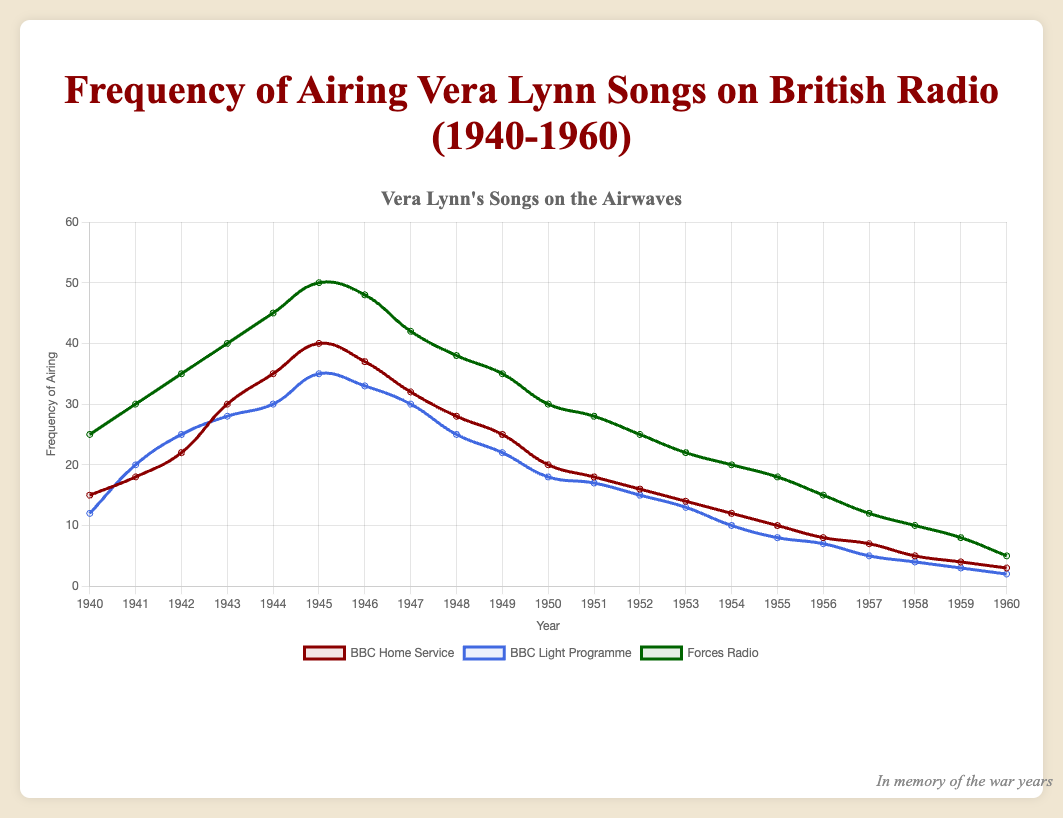Which year had the highest frequency of Vera Lynn songs on the Forces Radio? The year 1945 had the highest frequency of Vera Lynn songs on Forces Radio, with 50 airings. This can be observed by finding the peak point of the green line representing Forces Radio on the chart.
Answer: 1945 Comparing between 1943 and 1944, which radio service increased the most in airing Vera Lynn songs? From 1943 to 1944, BBC Home Service increased from 30 to 35 (a difference of 5), BBC Light Programme increased from 28 to 30 (a difference of 2), and Forces Radio increased from 40 to 45 (a difference of 5). Therefore, both BBC Home Service and Forces Radio had the most significant increase.
Answer: BBC Home Service and Forces Radio What is the difference in the frequency of airing Vera Lynn songs between the Forces Radio and BBC Home Service in 1942? In 1942, BBC Home Service aired 22 times, and Forces Radio aired 35 times. The difference is calculated as 35 - 22.
Answer: 13 What is the average frequency of Vera Lynn songs aired on the BBC Light Programme between 1941 and 1945? Adding the frequencies from 1941 to 1945 on BBC Light Programme (20, 25, 28, 30, 35) and then dividing by the number of years (5): (20 + 25 + 28 + 30 + 35) / 5. The sum is 138, so the average is 138/5.
Answer: 27.6 In which year did the BBC Home Service and the BBC Light Programme air the same number of Vera Lynn songs? By observing the red and blue lines, both lines intersect in the year 1940 where the BBC Home Service had 15 airings and BBC Light Programme had 12 airings. Therefore, there is no year where they had the same number of airings throughout the given period.
Answer: None How did the frequency of airings on the Forces Radio in 1950 compare to that in 1960? In 1950, the Forces Radio aired Vera Lynn songs 30 times, whereas in 1960, it aired them 5 times. The frequency in 1950 is significantly higher than in 1960.
Answer: Higher in 1950 What is the overall trend of Vera Lynn's songs airing on all three radio services from 1940 to 1960? The overall trend for all three radio services - BBC Home Service, BBC Light Programme, and Forces Radio - shows an initial increase in frequency until around the mid-1940s followed by a gradual decrease towards 1960. This is observed by the general rise and fall shape of all three lines on the chart.
Answer: Increase then decrease In 1945, which radio service aired Vera Lynn songs the most, and how many more than the least? In 1945, Forces Radio aired 50 times, BBC Home Service 40 times, and BBC Light Programme 35 times. Forces Radio aired the most at 50 times, which is 15 more than BBC Light Programme, the service that aired the least.
Answer: Forces Radio, 15 more What is the median value of Vera Lynn song airings on the BBC Home Service from 1940 to 1960? There are 21 values from 1940 to 1960 for BBC Home Service. Arranging them in order: (3, 4, 5, 7, 8, 10, 12, 14, 15, 16, 18, 18, 20, 22, 25, 28, 30, 32, 35, 37, 40), the middle value is 18 (the 11th value in an ordered set).
Answer: 18 